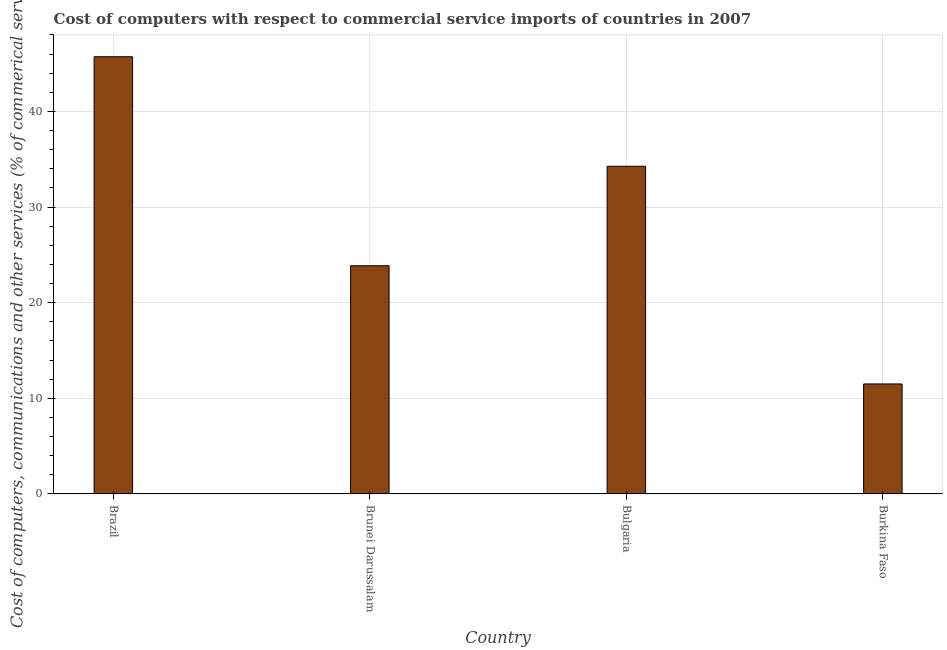Does the graph contain any zero values?
Give a very brief answer. No. Does the graph contain grids?
Provide a short and direct response. Yes. What is the title of the graph?
Your answer should be very brief. Cost of computers with respect to commercial service imports of countries in 2007. What is the label or title of the X-axis?
Keep it short and to the point. Country. What is the label or title of the Y-axis?
Offer a terse response. Cost of computers, communications and other services (% of commerical service exports). What is the  computer and other services in Burkina Faso?
Your response must be concise. 11.51. Across all countries, what is the maximum  computer and other services?
Offer a very short reply. 45.72. Across all countries, what is the minimum  computer and other services?
Your answer should be compact. 11.51. In which country was the  computer and other services maximum?
Make the answer very short. Brazil. In which country was the  computer and other services minimum?
Offer a very short reply. Burkina Faso. What is the sum of the cost of communications?
Your answer should be compact. 115.37. What is the difference between the  computer and other services in Brunei Darussalam and Bulgaria?
Keep it short and to the point. -10.4. What is the average  computer and other services per country?
Give a very brief answer. 28.84. What is the median  computer and other services?
Make the answer very short. 29.07. What is the ratio of the  computer and other services in Bulgaria to that in Burkina Faso?
Offer a terse response. 2.98. Is the cost of communications in Brazil less than that in Brunei Darussalam?
Your answer should be compact. No. What is the difference between the highest and the second highest cost of communications?
Offer a very short reply. 11.45. What is the difference between the highest and the lowest cost of communications?
Give a very brief answer. 34.22. In how many countries, is the  computer and other services greater than the average  computer and other services taken over all countries?
Your answer should be compact. 2. Are all the bars in the graph horizontal?
Your response must be concise. No. How many countries are there in the graph?
Your response must be concise. 4. What is the difference between two consecutive major ticks on the Y-axis?
Give a very brief answer. 10. What is the Cost of computers, communications and other services (% of commerical service exports) in Brazil?
Ensure brevity in your answer.  45.72. What is the Cost of computers, communications and other services (% of commerical service exports) of Brunei Darussalam?
Give a very brief answer. 23.87. What is the Cost of computers, communications and other services (% of commerical service exports) in Bulgaria?
Give a very brief answer. 34.27. What is the Cost of computers, communications and other services (% of commerical service exports) in Burkina Faso?
Offer a very short reply. 11.51. What is the difference between the Cost of computers, communications and other services (% of commerical service exports) in Brazil and Brunei Darussalam?
Keep it short and to the point. 21.86. What is the difference between the Cost of computers, communications and other services (% of commerical service exports) in Brazil and Bulgaria?
Your answer should be compact. 11.45. What is the difference between the Cost of computers, communications and other services (% of commerical service exports) in Brazil and Burkina Faso?
Provide a succinct answer. 34.22. What is the difference between the Cost of computers, communications and other services (% of commerical service exports) in Brunei Darussalam and Bulgaria?
Offer a terse response. -10.41. What is the difference between the Cost of computers, communications and other services (% of commerical service exports) in Brunei Darussalam and Burkina Faso?
Ensure brevity in your answer.  12.36. What is the difference between the Cost of computers, communications and other services (% of commerical service exports) in Bulgaria and Burkina Faso?
Offer a very short reply. 22.77. What is the ratio of the Cost of computers, communications and other services (% of commerical service exports) in Brazil to that in Brunei Darussalam?
Your response must be concise. 1.92. What is the ratio of the Cost of computers, communications and other services (% of commerical service exports) in Brazil to that in Bulgaria?
Ensure brevity in your answer.  1.33. What is the ratio of the Cost of computers, communications and other services (% of commerical service exports) in Brazil to that in Burkina Faso?
Ensure brevity in your answer.  3.97. What is the ratio of the Cost of computers, communications and other services (% of commerical service exports) in Brunei Darussalam to that in Bulgaria?
Your response must be concise. 0.7. What is the ratio of the Cost of computers, communications and other services (% of commerical service exports) in Brunei Darussalam to that in Burkina Faso?
Your answer should be very brief. 2.07. What is the ratio of the Cost of computers, communications and other services (% of commerical service exports) in Bulgaria to that in Burkina Faso?
Your answer should be very brief. 2.98. 